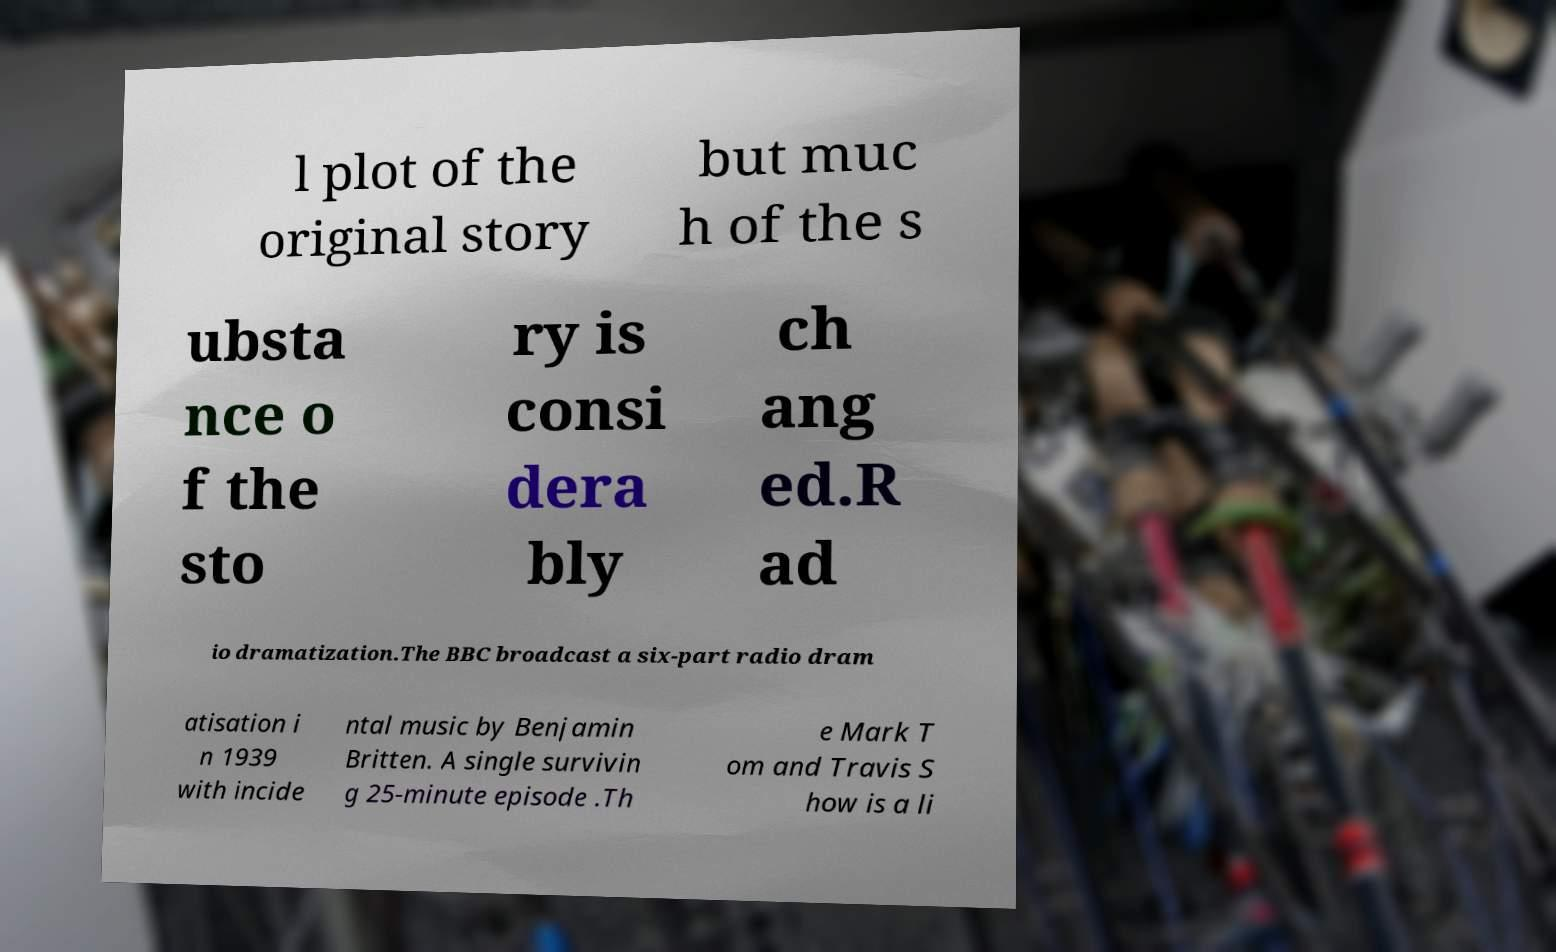Could you assist in decoding the text presented in this image and type it out clearly? l plot of the original story but muc h of the s ubsta nce o f the sto ry is consi dera bly ch ang ed.R ad io dramatization.The BBC broadcast a six-part radio dram atisation i n 1939 with incide ntal music by Benjamin Britten. A single survivin g 25-minute episode .Th e Mark T om and Travis S how is a li 